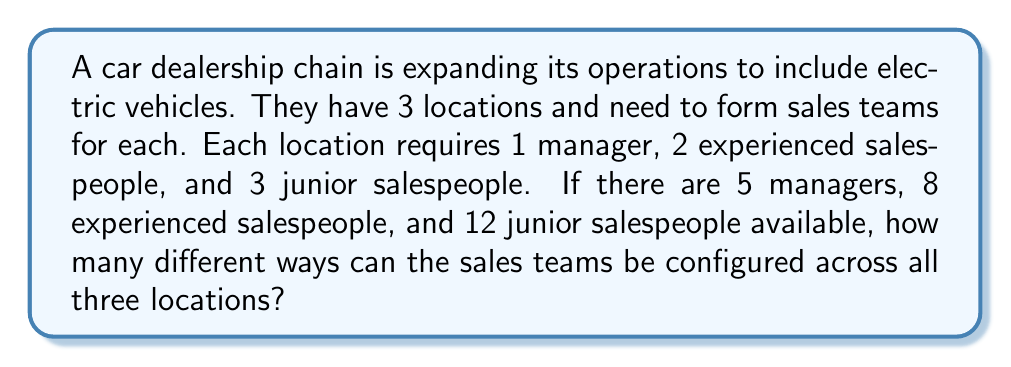What is the answer to this math problem? Let's approach this step-by-step:

1) First, we need to choose managers for each location:
   $${5 \choose 1}{4 \choose 1}{3 \choose 1} = 5 \cdot 4 \cdot 3 = 60$$

2) Next, we choose experienced salespeople for each location:
   $${8 \choose 2}{6 \choose 2}{4 \choose 2} = 28 \cdot 15 \cdot 6 = 2,520$$

3) Finally, we choose junior salespeople for each location:
   $${12 \choose 3}{9 \choose 3}{6 \choose 3} = 220 \cdot 84 \cdot 20 = 369,600$$

4) By the multiplication principle, the total number of ways to configure the sales teams is:
   $$60 \cdot 2,520 \cdot 369,600 = 55,987,200,000$$

Therefore, there are 55,987,200,000 different ways to configure the sales teams across all three locations.
Answer: 55,987,200,000 